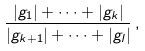Convert formula to latex. <formula><loc_0><loc_0><loc_500><loc_500>\frac { | g _ { 1 } | + \dots + | g _ { k } | } { | g _ { k + 1 } | + \dots + | g _ { l } | } \, ,</formula> 